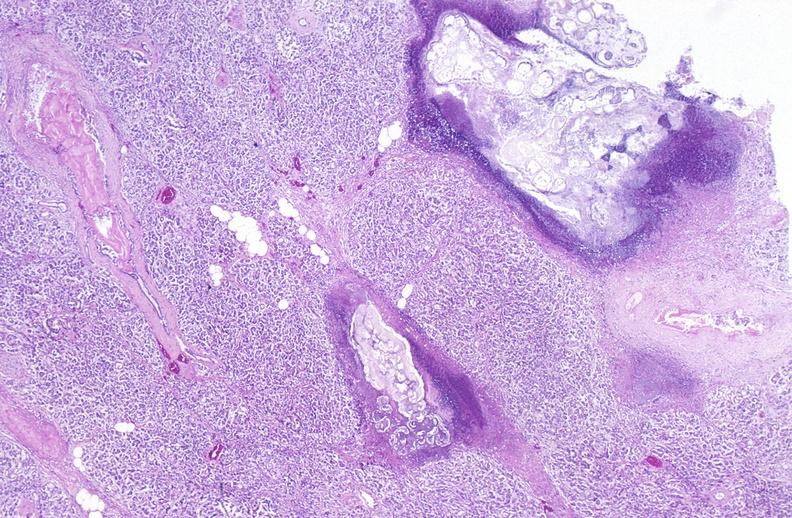where is this?
Answer the question using a single word or phrase. Pancreas 